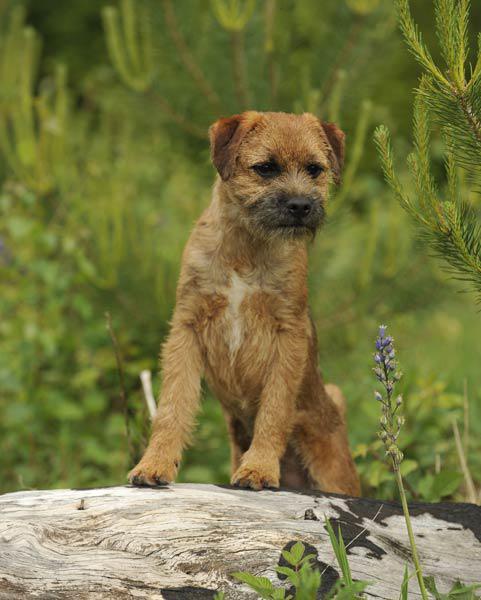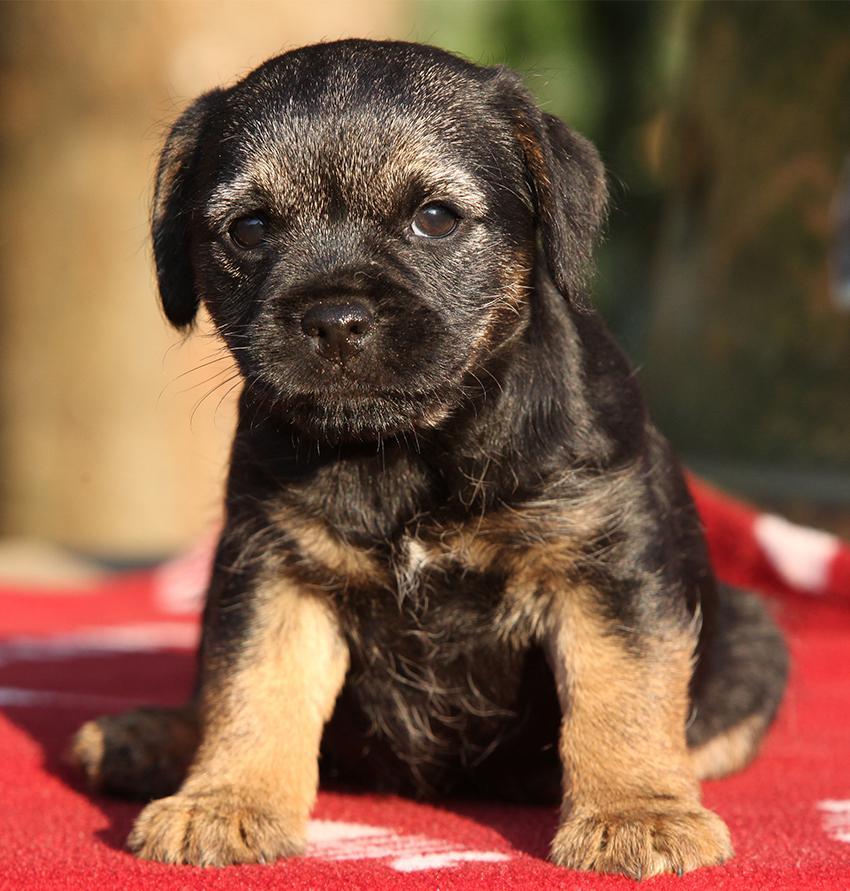The first image is the image on the left, the second image is the image on the right. Given the left and right images, does the statement "In one image a dog is in the grass, moving forward with its left leg higher than the right and has its mouth open." hold true? Answer yes or no. No. 